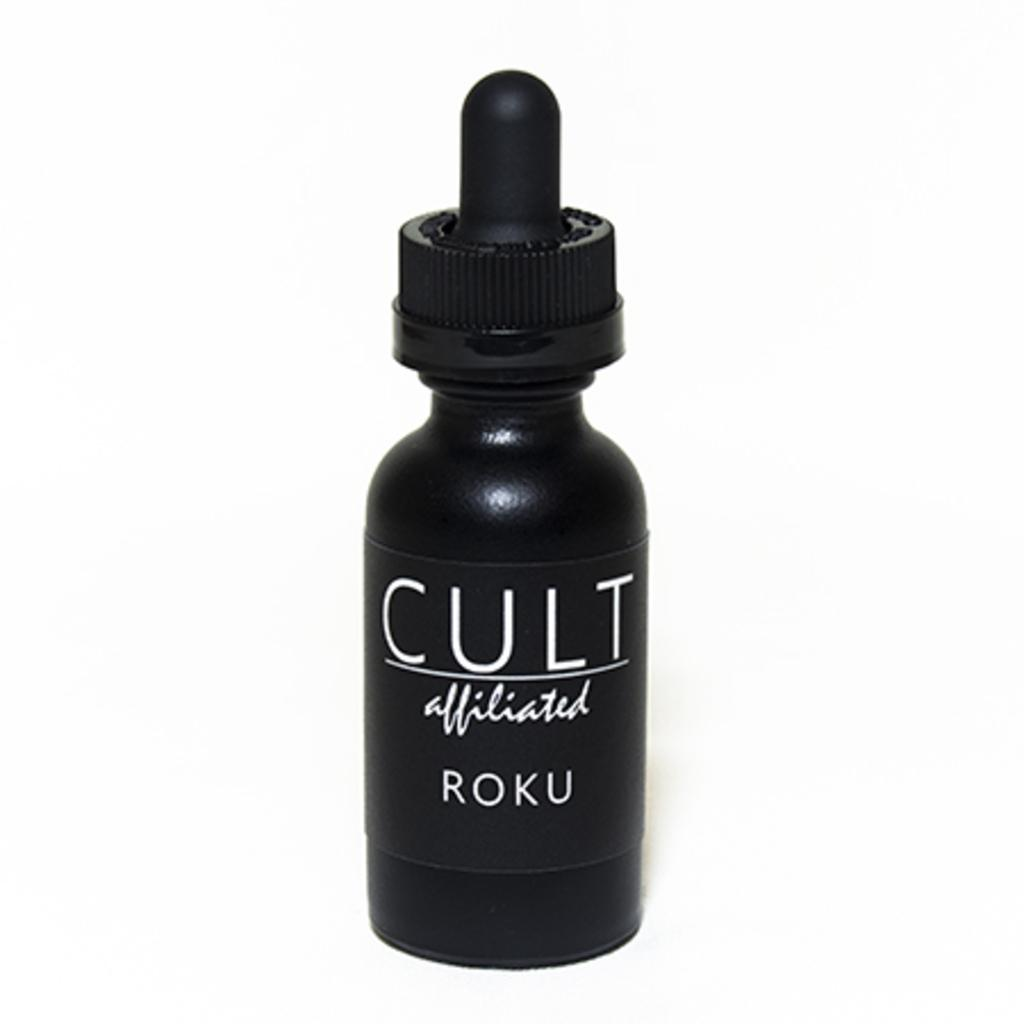<image>
Offer a succinct explanation of the picture presented. A black bottle hase white lettering of "cult affiliated roku." 